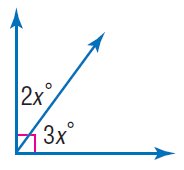Answer the mathemtical geometry problem and directly provide the correct option letter.
Question: Find x.
Choices: A: 18 B: 27 C: 36 D: 72 A 